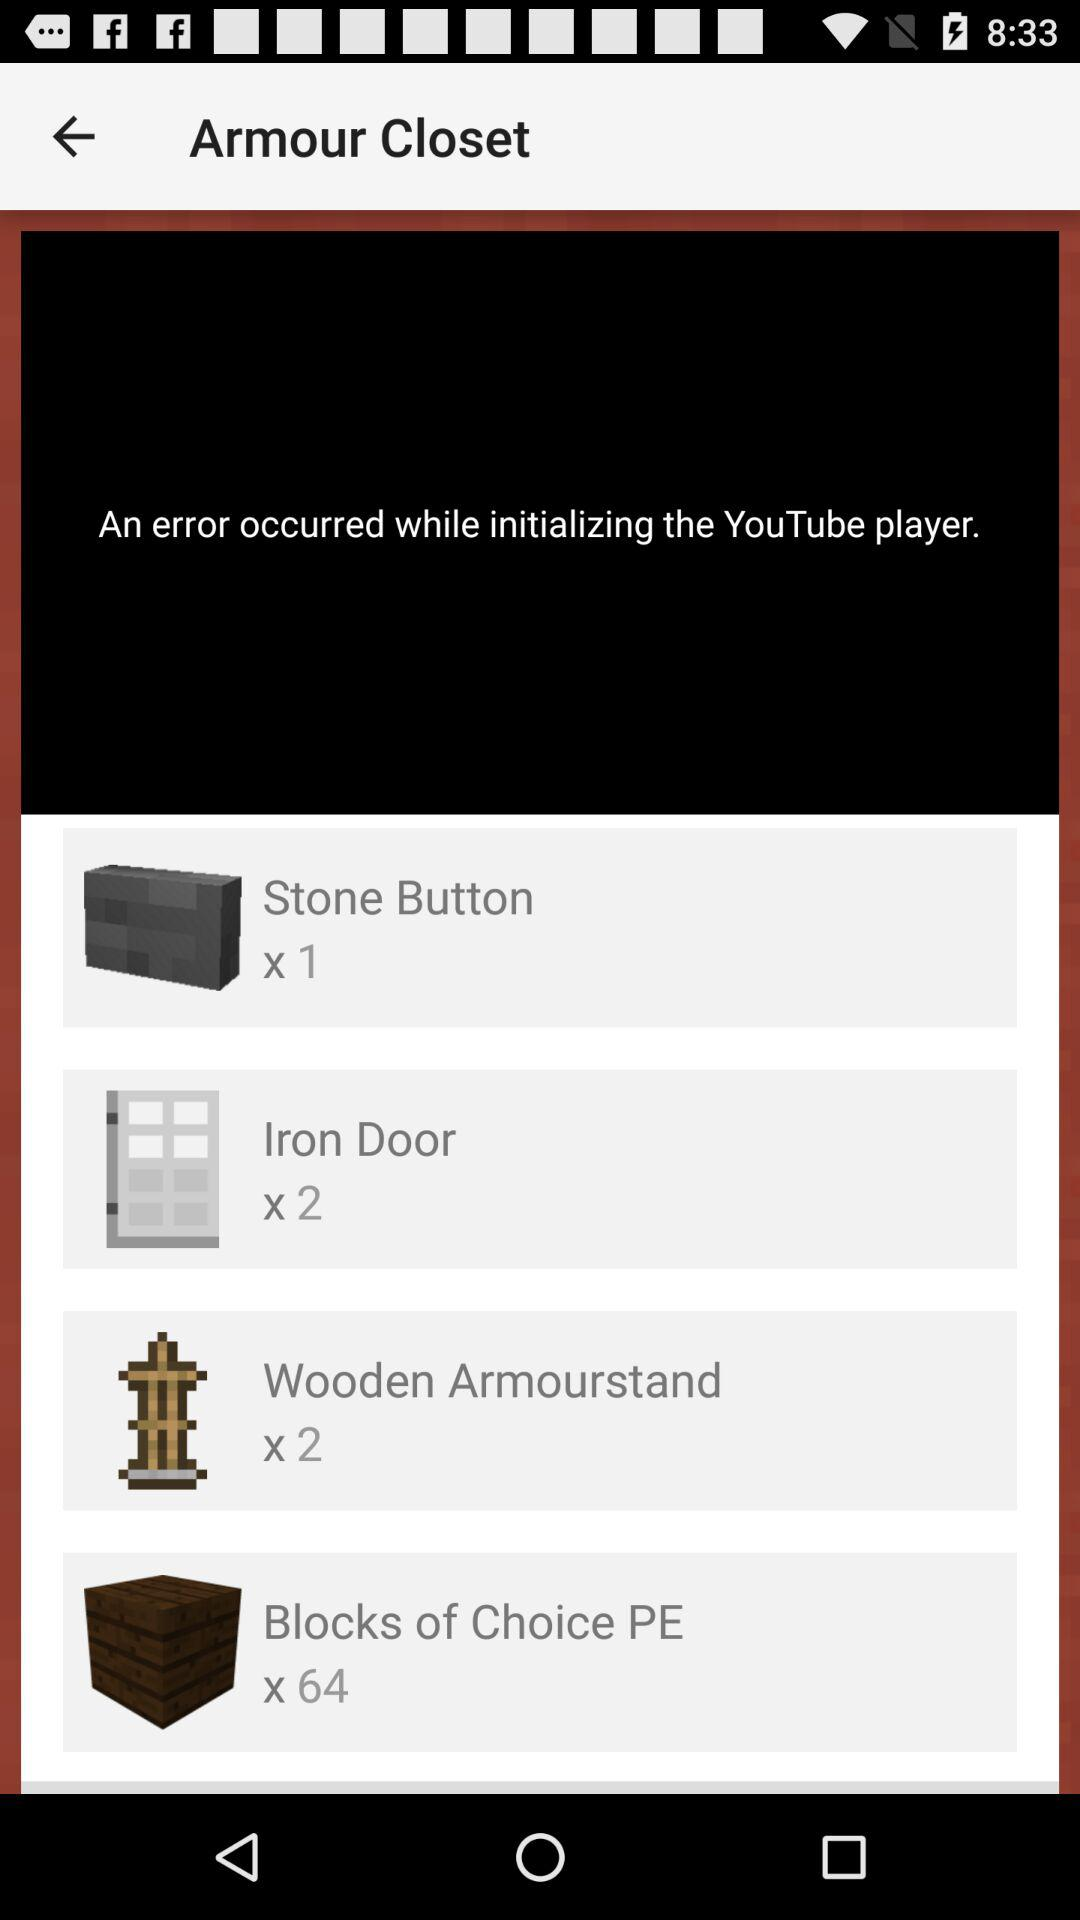How many iron doors are there? There are 2 iron doors. 